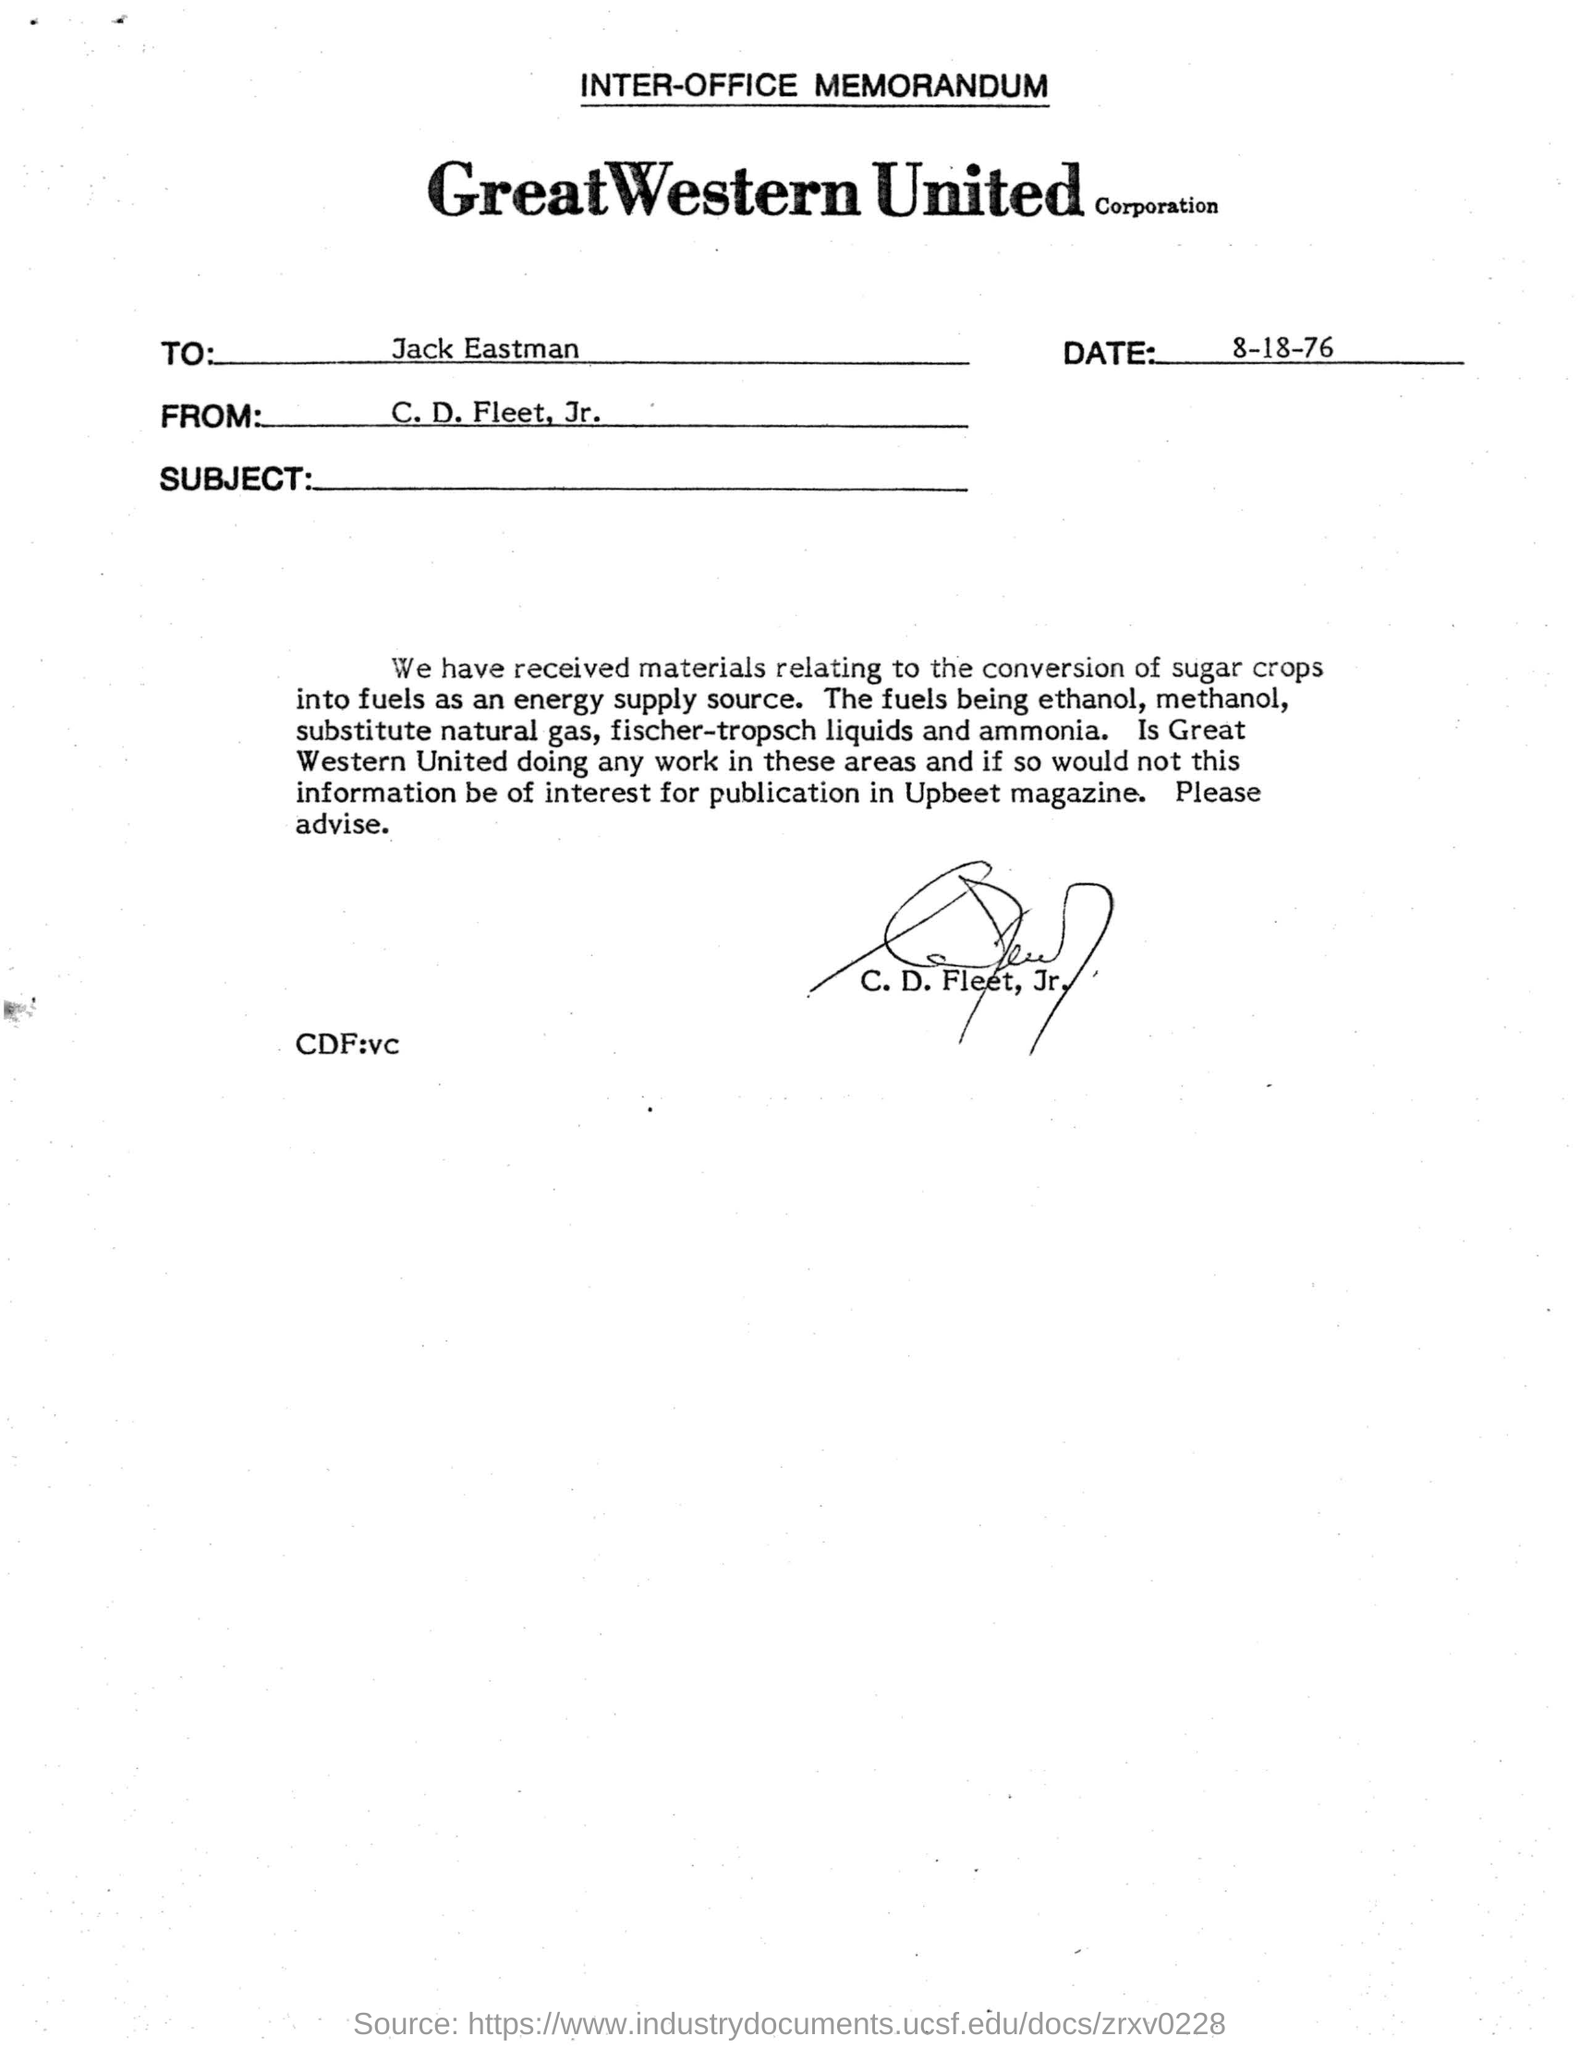Give some essential details in this illustration. The date mentioned is 8-18-76. The document has been signed by C. D. Fleet, Jr. The memorandum is signed by C. D. Fleet, Jr. The document is addressed to Jack Eastman. 